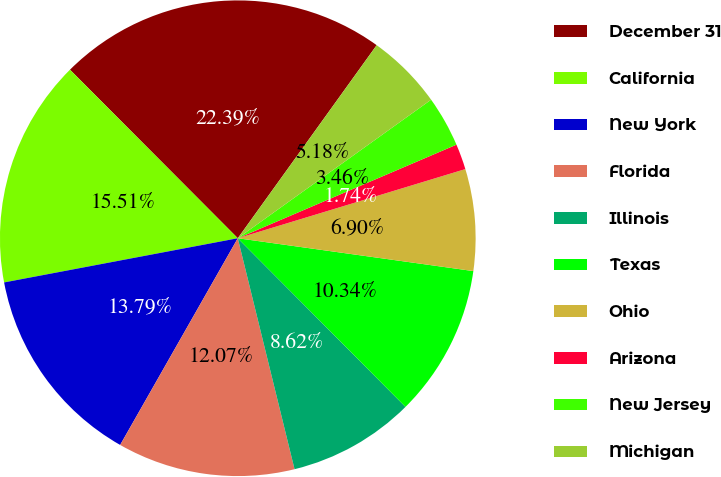<chart> <loc_0><loc_0><loc_500><loc_500><pie_chart><fcel>December 31<fcel>California<fcel>New York<fcel>Florida<fcel>Illinois<fcel>Texas<fcel>Ohio<fcel>Arizona<fcel>New Jersey<fcel>Michigan<nl><fcel>22.39%<fcel>15.51%<fcel>13.79%<fcel>12.07%<fcel>8.62%<fcel>10.34%<fcel>6.9%<fcel>1.74%<fcel>3.46%<fcel>5.18%<nl></chart> 